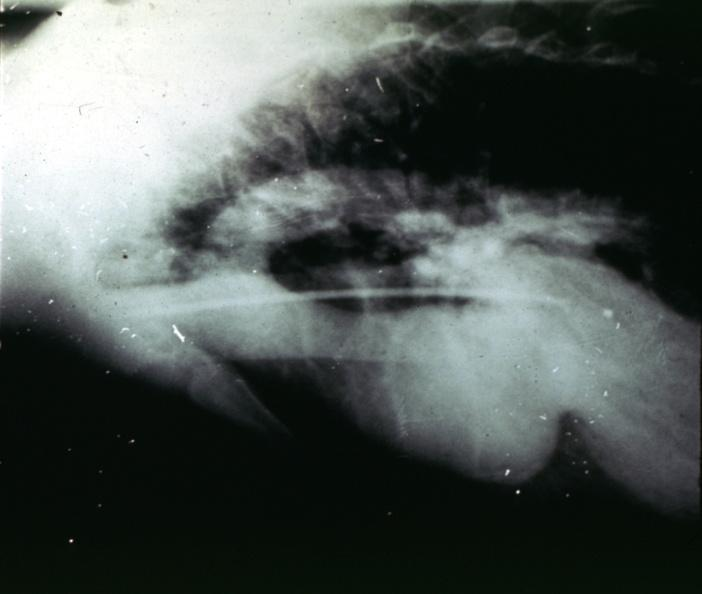s cardiovascular present?
Answer the question using a single word or phrase. Yes 